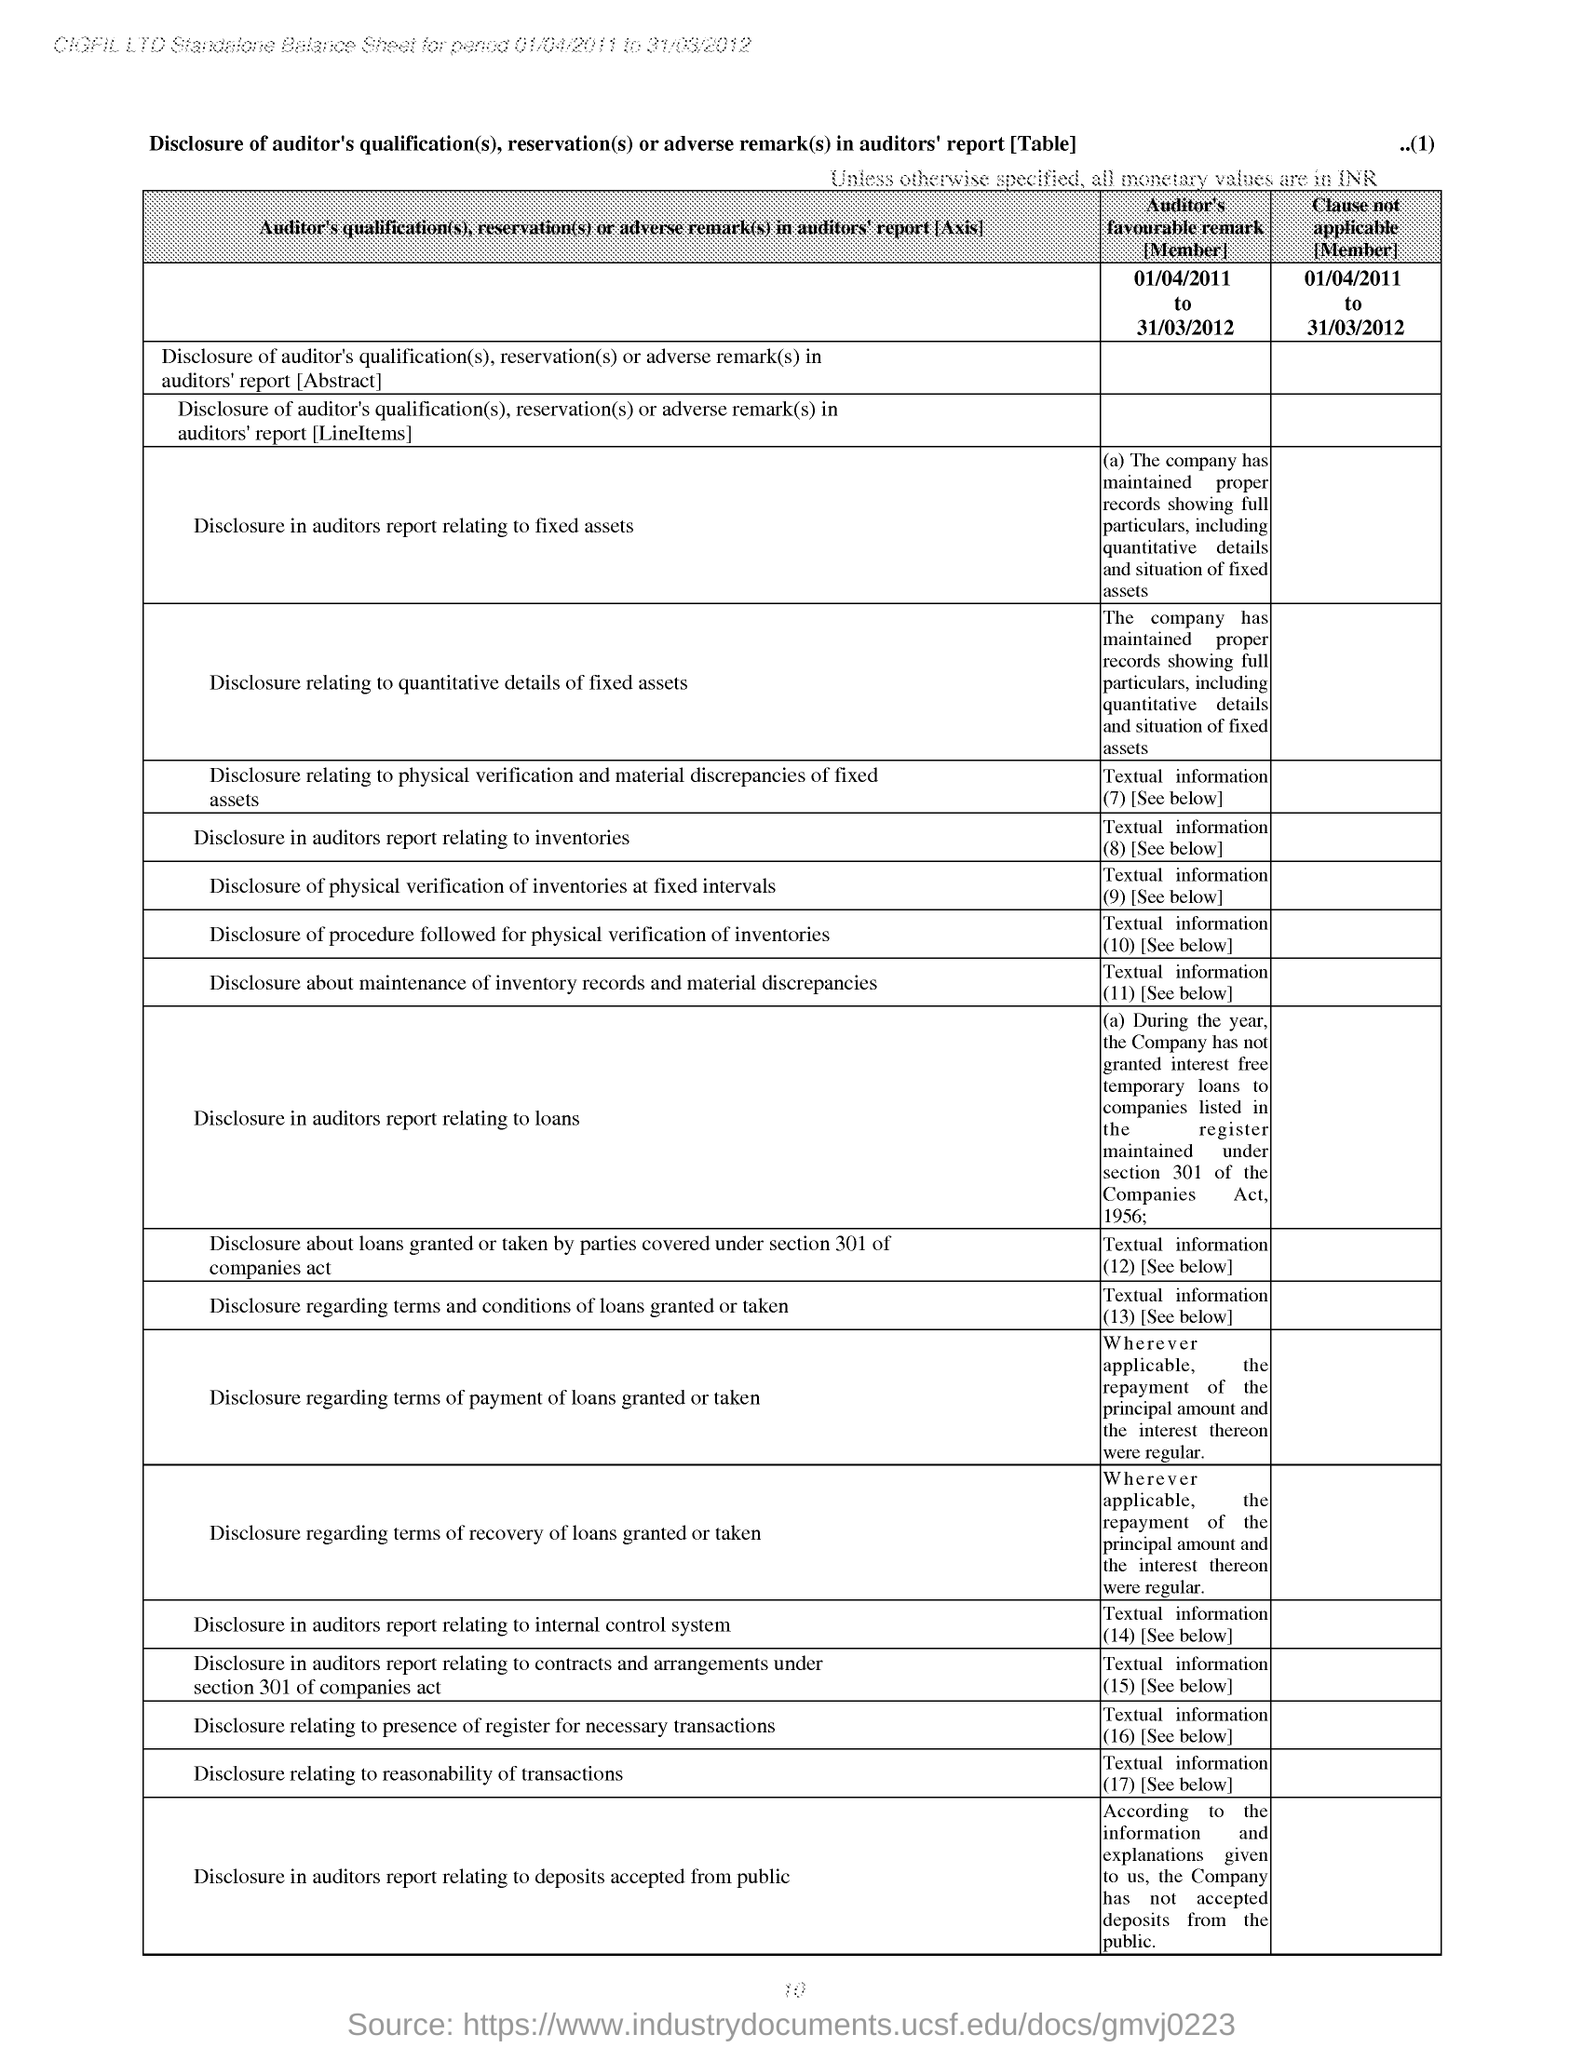How all monetary values are considered unless specified particularly?
Your answer should be very brief. INR. Balance sheet is made for which period?
Offer a very short reply. 01/04/2011 to 31/03/2012. In  "Disclosure in auditors report relating to loans" which "Section" is mentioned by AUDITOR?
Your answer should be very brief. Section  301. In "Disclosure in auditors report relating to loans" COMPANIES ACT of which year is mentioned by AUDITOR?
Provide a short and direct response. 1956. What is the Page number given at the top right corner of the page?
Make the answer very short. 1. 